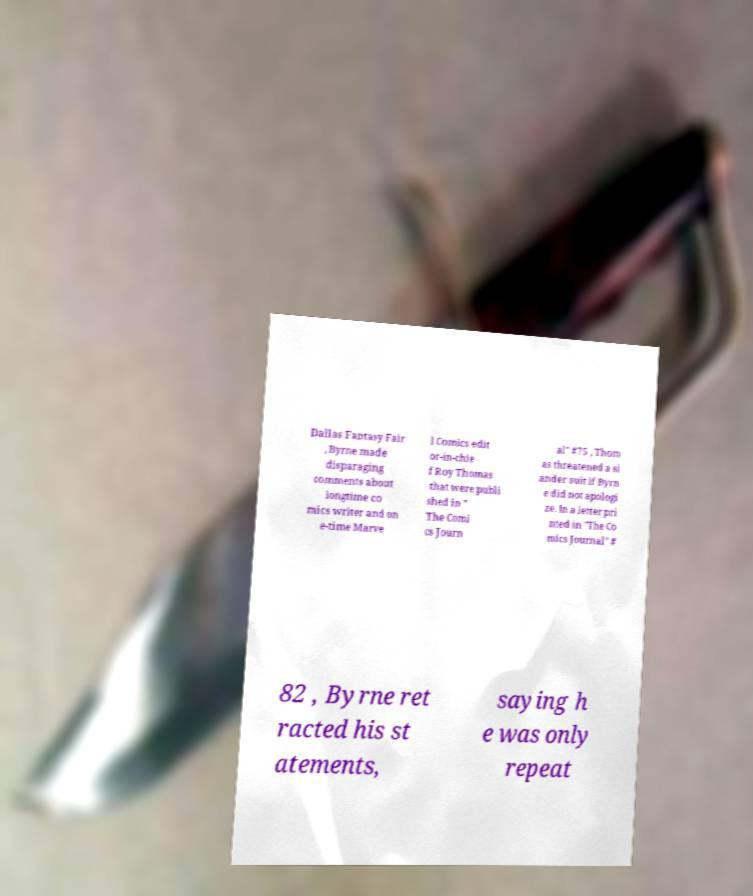For documentation purposes, I need the text within this image transcribed. Could you provide that? Dallas Fantasy Fair , Byrne made disparaging comments about longtime co mics writer and on e-time Marve l Comics edit or-in-chie f Roy Thomas that were publi shed in " The Comi cs Journ al" #75 , Thom as threatened a sl ander suit if Byrn e did not apologi ze. In a letter pri nted in "The Co mics Journal" # 82 , Byrne ret racted his st atements, saying h e was only repeat 